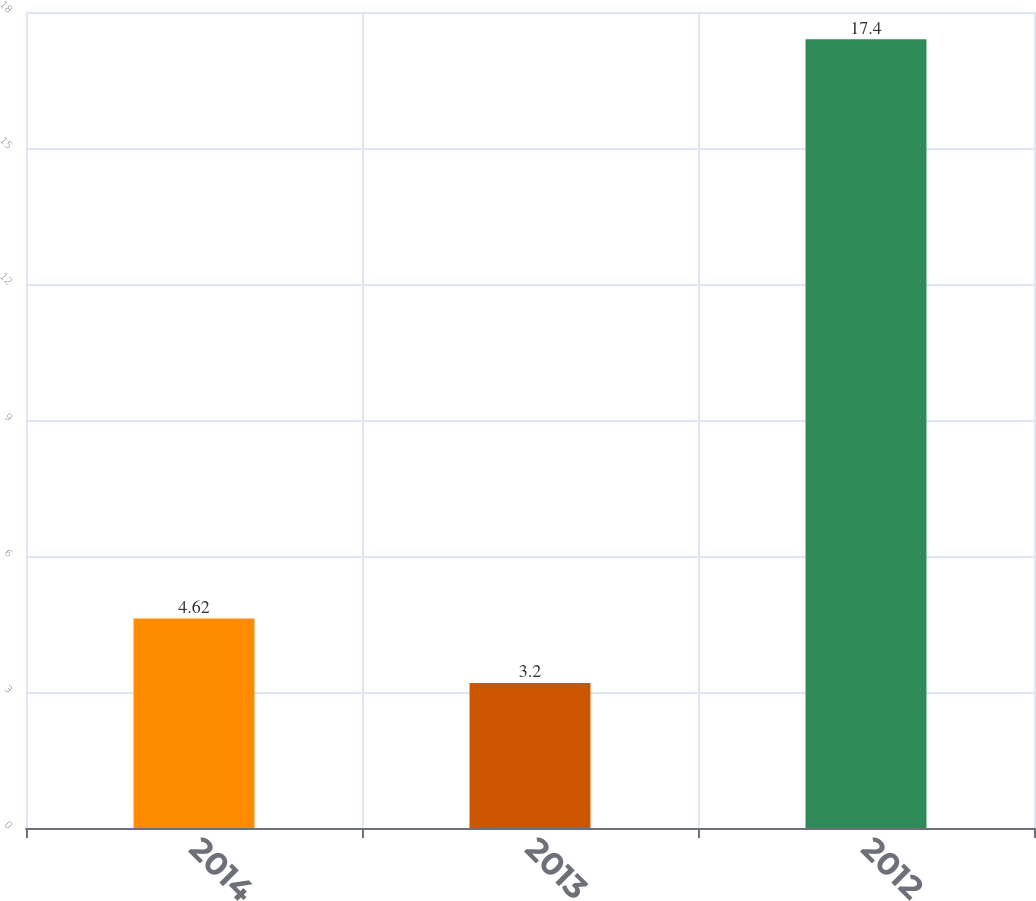Convert chart. <chart><loc_0><loc_0><loc_500><loc_500><bar_chart><fcel>2014<fcel>2013<fcel>2012<nl><fcel>4.62<fcel>3.2<fcel>17.4<nl></chart> 